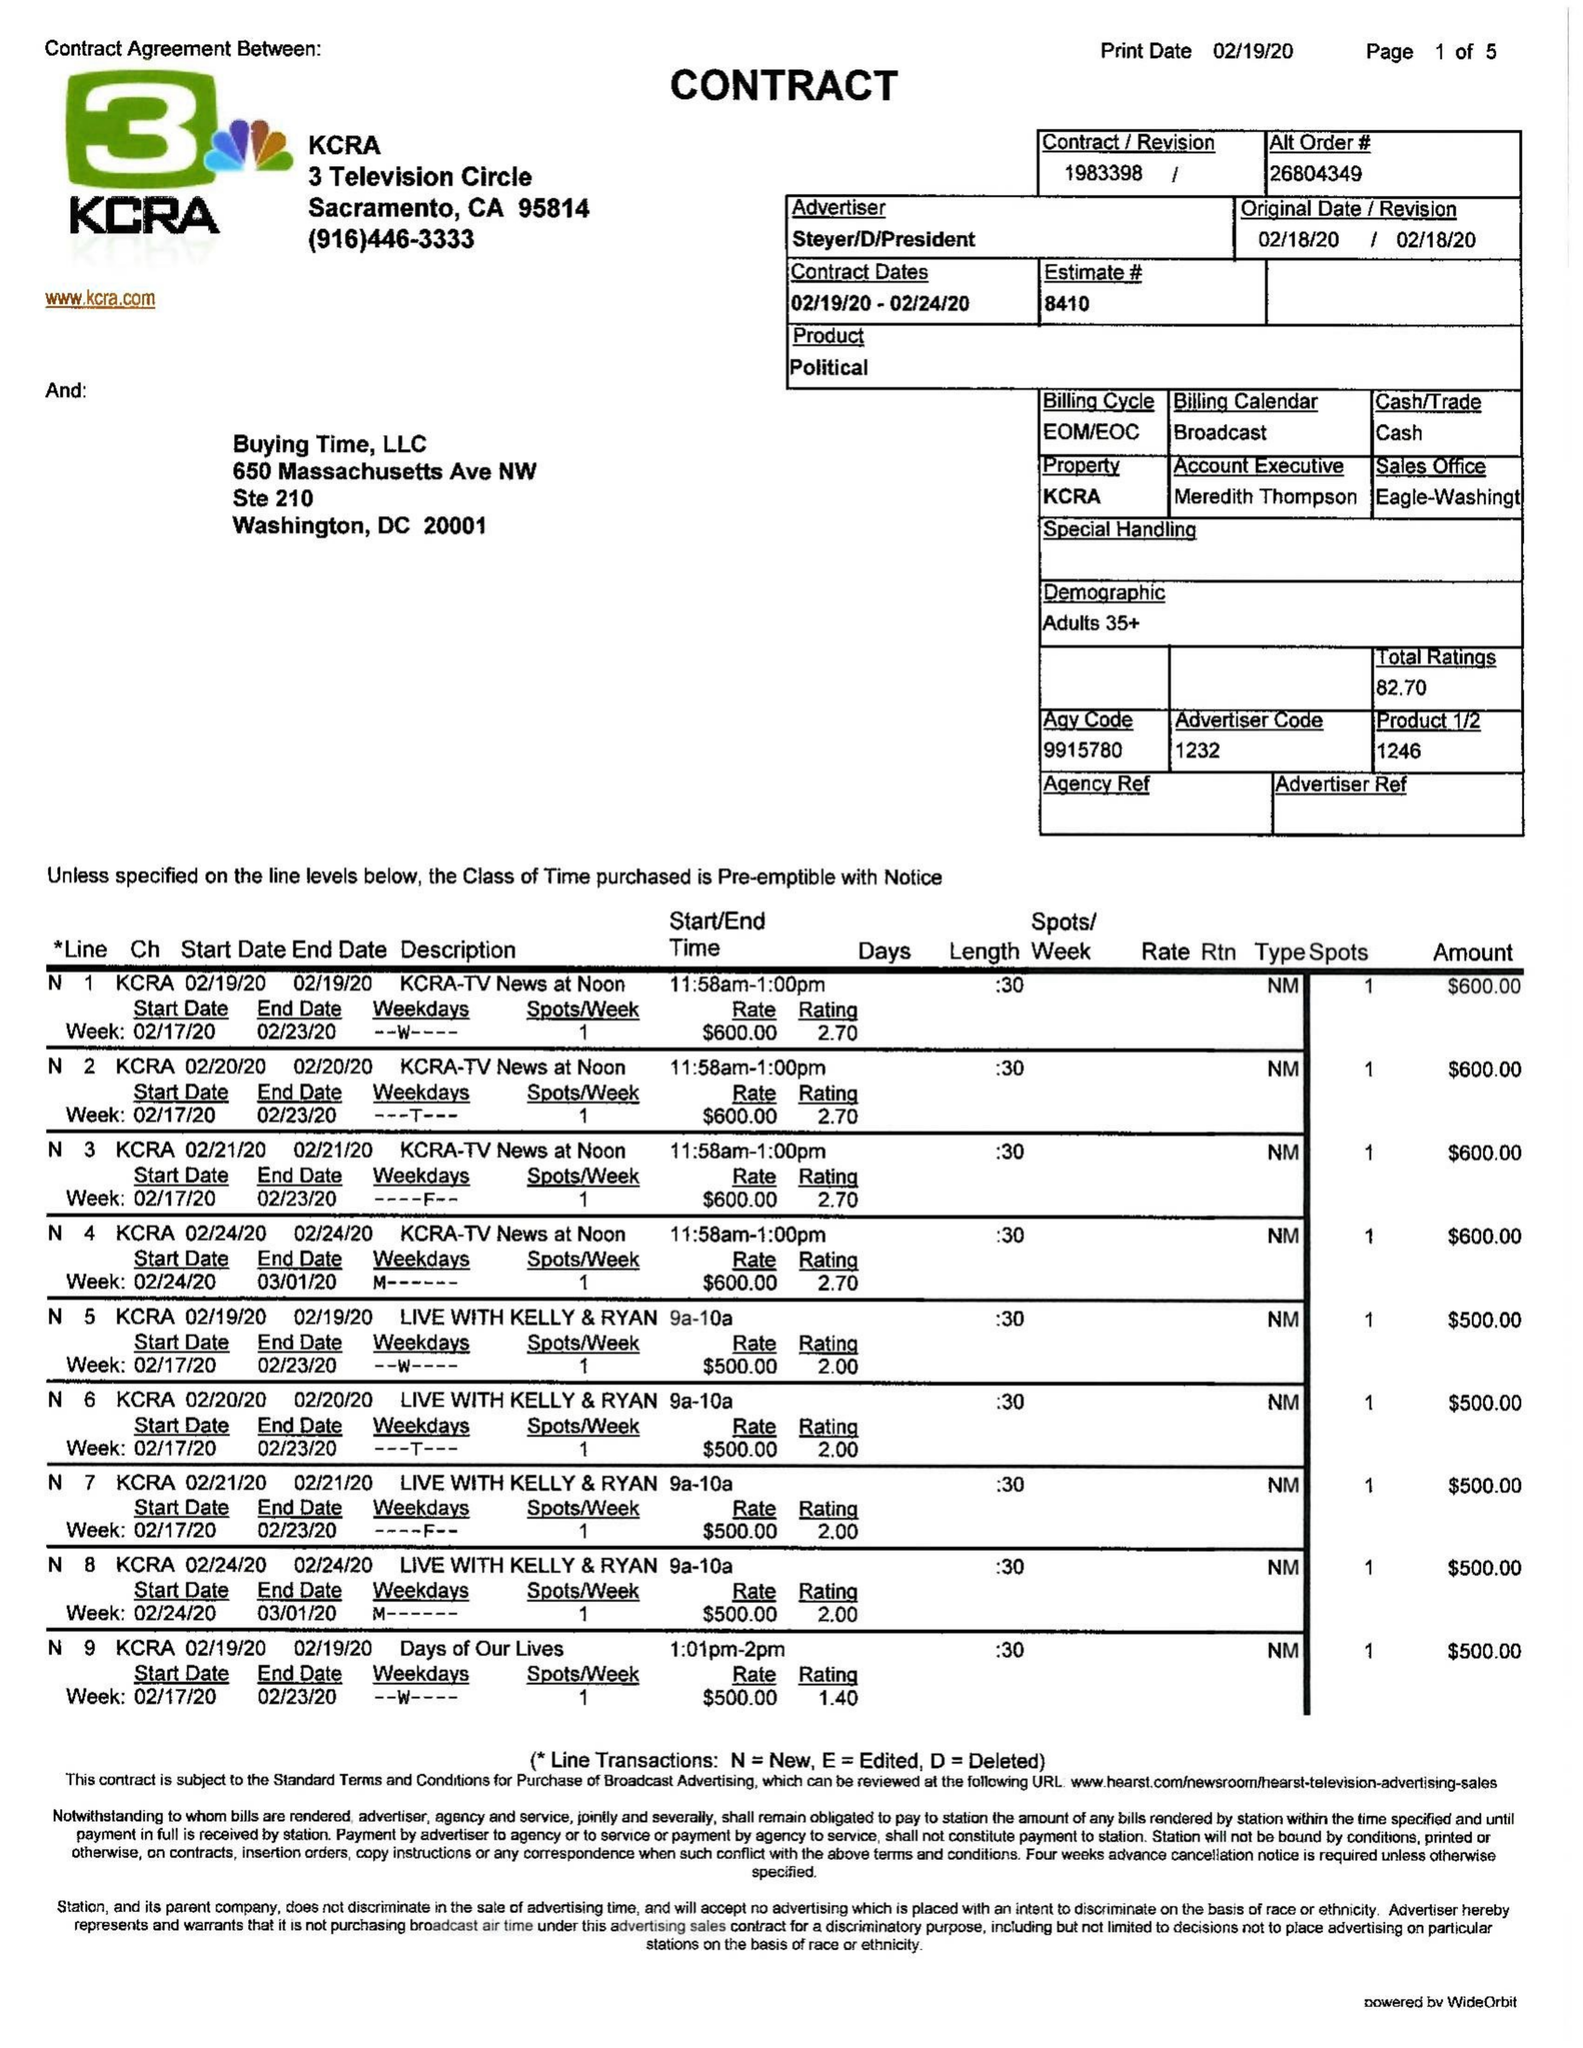What is the value for the gross_amount?
Answer the question using a single word or phrase. 22800.00 